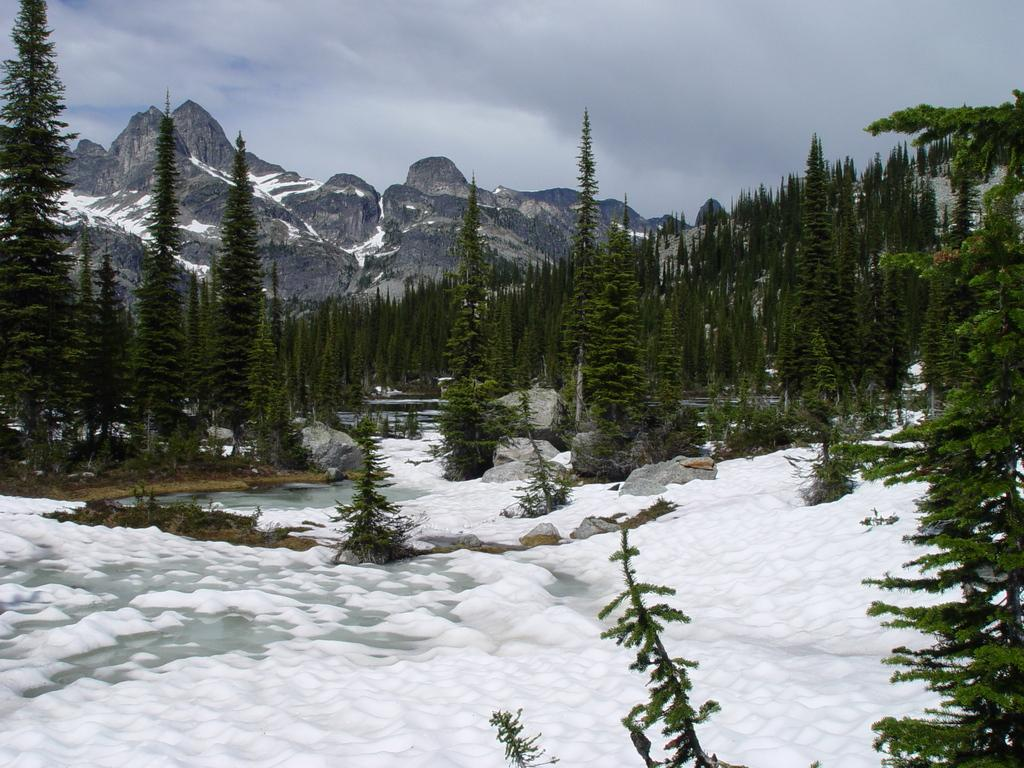What type of environment is depicted in the image? The image displays a beautiful view of nature. What is covering the ground in the image? There is snow on the ground in the image. Can you describe any specific features of the landscape? There is a tall tree visible in the image. What can be seen in the distance in the image? In the background, there are mountains with snow. What type of vest is the hospital wearing in the image? There is no hospital or vest present in the image; it features a natural landscape with snow. 